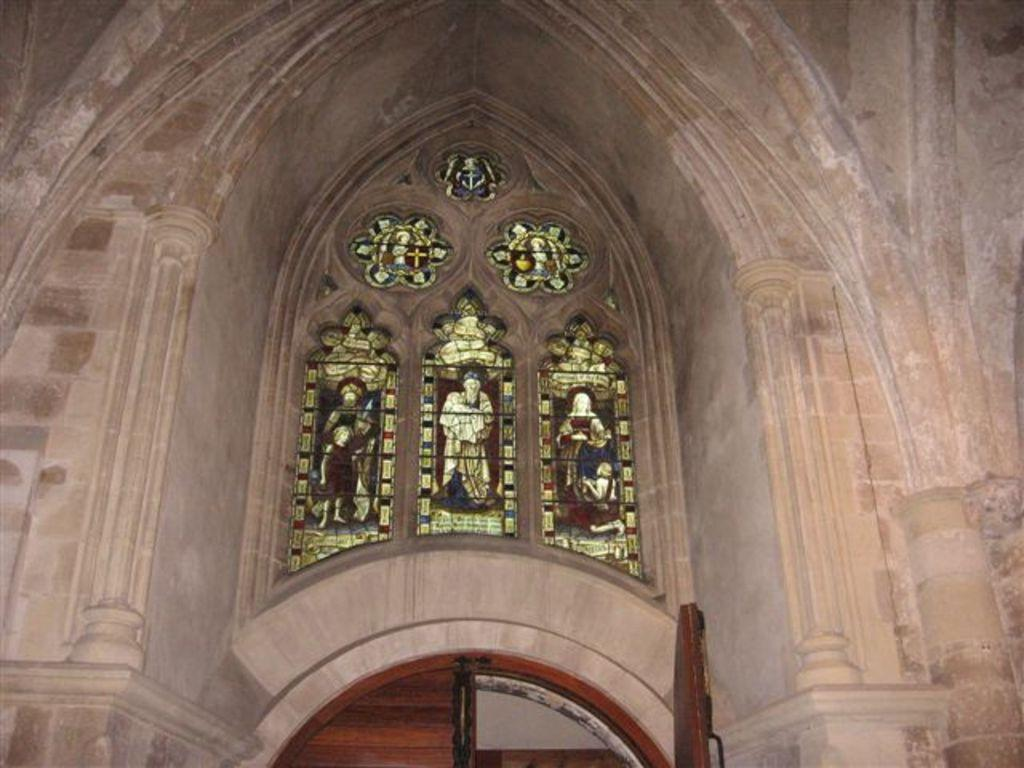What is the main structure in the center of the image? There is an arch in the center of the image. What is located at the bottom side of the image? There is a door at the bottom side of the image. What type of material is used for the windows in the image? There are glass windows in the image. What can be seen in the center of the glass windows? There is a painting in the center of the glass windows. What type of cup is being used to catch the snow in the image? There is no snow or cup present in the image. 